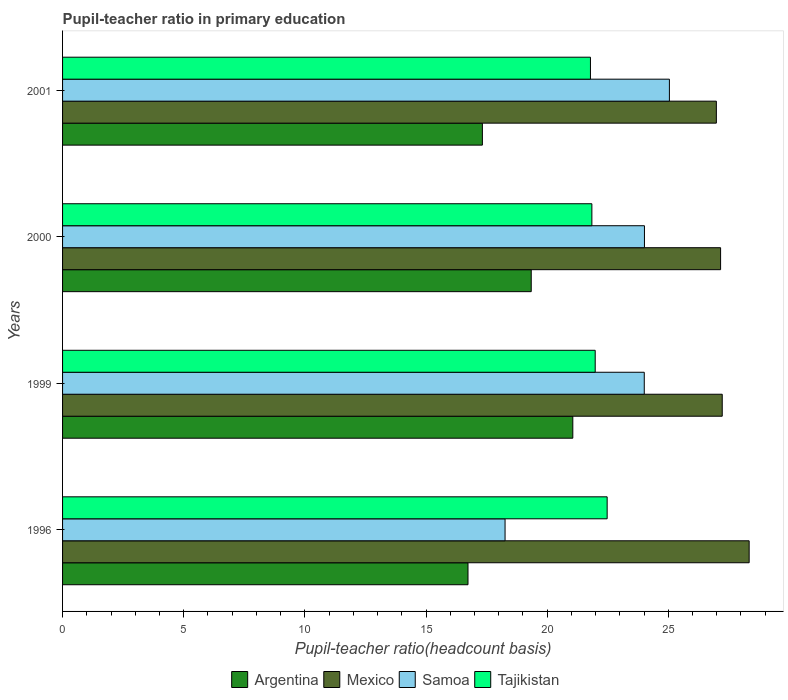Are the number of bars on each tick of the Y-axis equal?
Keep it short and to the point. Yes. What is the label of the 3rd group of bars from the top?
Your answer should be compact. 1999. What is the pupil-teacher ratio in primary education in Samoa in 1996?
Your answer should be very brief. 18.26. Across all years, what is the maximum pupil-teacher ratio in primary education in Mexico?
Ensure brevity in your answer.  28.34. Across all years, what is the minimum pupil-teacher ratio in primary education in Mexico?
Provide a succinct answer. 26.98. In which year was the pupil-teacher ratio in primary education in Mexico maximum?
Provide a short and direct response. 1996. What is the total pupil-teacher ratio in primary education in Mexico in the graph?
Ensure brevity in your answer.  109.7. What is the difference between the pupil-teacher ratio in primary education in Samoa in 1996 and that in 2001?
Provide a succinct answer. -6.78. What is the difference between the pupil-teacher ratio in primary education in Tajikistan in 1996 and the pupil-teacher ratio in primary education in Argentina in 2000?
Keep it short and to the point. 3.13. What is the average pupil-teacher ratio in primary education in Mexico per year?
Offer a very short reply. 27.43. In the year 2000, what is the difference between the pupil-teacher ratio in primary education in Samoa and pupil-teacher ratio in primary education in Argentina?
Offer a terse response. 4.67. What is the ratio of the pupil-teacher ratio in primary education in Argentina in 1999 to that in 2001?
Your answer should be very brief. 1.22. Is the pupil-teacher ratio in primary education in Tajikistan in 1999 less than that in 2000?
Make the answer very short. No. Is the difference between the pupil-teacher ratio in primary education in Samoa in 1999 and 2001 greater than the difference between the pupil-teacher ratio in primary education in Argentina in 1999 and 2001?
Keep it short and to the point. No. What is the difference between the highest and the second highest pupil-teacher ratio in primary education in Samoa?
Offer a terse response. 1.03. What is the difference between the highest and the lowest pupil-teacher ratio in primary education in Mexico?
Your answer should be compact. 1.35. In how many years, is the pupil-teacher ratio in primary education in Samoa greater than the average pupil-teacher ratio in primary education in Samoa taken over all years?
Provide a succinct answer. 3. Is it the case that in every year, the sum of the pupil-teacher ratio in primary education in Samoa and pupil-teacher ratio in primary education in Tajikistan is greater than the sum of pupil-teacher ratio in primary education in Argentina and pupil-teacher ratio in primary education in Mexico?
Provide a succinct answer. Yes. What does the 2nd bar from the top in 2001 represents?
Your answer should be compact. Samoa. What does the 2nd bar from the bottom in 1999 represents?
Your answer should be very brief. Mexico. Are all the bars in the graph horizontal?
Give a very brief answer. Yes. Are the values on the major ticks of X-axis written in scientific E-notation?
Offer a very short reply. No. Does the graph contain any zero values?
Your response must be concise. No. Where does the legend appear in the graph?
Your response must be concise. Bottom center. How many legend labels are there?
Offer a terse response. 4. How are the legend labels stacked?
Provide a short and direct response. Horizontal. What is the title of the graph?
Keep it short and to the point. Pupil-teacher ratio in primary education. What is the label or title of the X-axis?
Provide a succinct answer. Pupil-teacher ratio(headcount basis). What is the Pupil-teacher ratio(headcount basis) in Argentina in 1996?
Your answer should be very brief. 16.73. What is the Pupil-teacher ratio(headcount basis) in Mexico in 1996?
Your response must be concise. 28.34. What is the Pupil-teacher ratio(headcount basis) of Samoa in 1996?
Keep it short and to the point. 18.26. What is the Pupil-teacher ratio(headcount basis) of Tajikistan in 1996?
Your answer should be very brief. 22.48. What is the Pupil-teacher ratio(headcount basis) in Argentina in 1999?
Provide a succinct answer. 21.06. What is the Pupil-teacher ratio(headcount basis) in Mexico in 1999?
Provide a short and direct response. 27.23. What is the Pupil-teacher ratio(headcount basis) of Samoa in 1999?
Your answer should be very brief. 24.01. What is the Pupil-teacher ratio(headcount basis) in Tajikistan in 1999?
Provide a short and direct response. 21.98. What is the Pupil-teacher ratio(headcount basis) in Argentina in 2000?
Your answer should be compact. 19.34. What is the Pupil-teacher ratio(headcount basis) in Mexico in 2000?
Keep it short and to the point. 27.16. What is the Pupil-teacher ratio(headcount basis) of Samoa in 2000?
Your answer should be compact. 24.02. What is the Pupil-teacher ratio(headcount basis) in Tajikistan in 2000?
Provide a short and direct response. 21.85. What is the Pupil-teacher ratio(headcount basis) of Argentina in 2001?
Offer a very short reply. 17.33. What is the Pupil-teacher ratio(headcount basis) of Mexico in 2001?
Provide a succinct answer. 26.98. What is the Pupil-teacher ratio(headcount basis) of Samoa in 2001?
Ensure brevity in your answer.  25.05. What is the Pupil-teacher ratio(headcount basis) of Tajikistan in 2001?
Offer a very short reply. 21.79. Across all years, what is the maximum Pupil-teacher ratio(headcount basis) in Argentina?
Provide a succinct answer. 21.06. Across all years, what is the maximum Pupil-teacher ratio(headcount basis) in Mexico?
Offer a very short reply. 28.34. Across all years, what is the maximum Pupil-teacher ratio(headcount basis) of Samoa?
Give a very brief answer. 25.05. Across all years, what is the maximum Pupil-teacher ratio(headcount basis) of Tajikistan?
Provide a short and direct response. 22.48. Across all years, what is the minimum Pupil-teacher ratio(headcount basis) of Argentina?
Provide a succinct answer. 16.73. Across all years, what is the minimum Pupil-teacher ratio(headcount basis) of Mexico?
Ensure brevity in your answer.  26.98. Across all years, what is the minimum Pupil-teacher ratio(headcount basis) of Samoa?
Offer a terse response. 18.26. Across all years, what is the minimum Pupil-teacher ratio(headcount basis) in Tajikistan?
Your answer should be compact. 21.79. What is the total Pupil-teacher ratio(headcount basis) in Argentina in the graph?
Provide a succinct answer. 74.46. What is the total Pupil-teacher ratio(headcount basis) in Mexico in the graph?
Keep it short and to the point. 109.7. What is the total Pupil-teacher ratio(headcount basis) in Samoa in the graph?
Make the answer very short. 91.33. What is the total Pupil-teacher ratio(headcount basis) of Tajikistan in the graph?
Your response must be concise. 88.09. What is the difference between the Pupil-teacher ratio(headcount basis) in Argentina in 1996 and that in 1999?
Your answer should be compact. -4.33. What is the difference between the Pupil-teacher ratio(headcount basis) of Mexico in 1996 and that in 1999?
Provide a short and direct response. 1.11. What is the difference between the Pupil-teacher ratio(headcount basis) of Samoa in 1996 and that in 1999?
Make the answer very short. -5.74. What is the difference between the Pupil-teacher ratio(headcount basis) of Tajikistan in 1996 and that in 1999?
Your answer should be very brief. 0.49. What is the difference between the Pupil-teacher ratio(headcount basis) of Argentina in 1996 and that in 2000?
Offer a terse response. -2.61. What is the difference between the Pupil-teacher ratio(headcount basis) in Mexico in 1996 and that in 2000?
Keep it short and to the point. 1.18. What is the difference between the Pupil-teacher ratio(headcount basis) in Samoa in 1996 and that in 2000?
Give a very brief answer. -5.75. What is the difference between the Pupil-teacher ratio(headcount basis) of Tajikistan in 1996 and that in 2000?
Offer a very short reply. 0.63. What is the difference between the Pupil-teacher ratio(headcount basis) in Argentina in 1996 and that in 2001?
Offer a very short reply. -0.59. What is the difference between the Pupil-teacher ratio(headcount basis) in Mexico in 1996 and that in 2001?
Give a very brief answer. 1.35. What is the difference between the Pupil-teacher ratio(headcount basis) of Samoa in 1996 and that in 2001?
Give a very brief answer. -6.78. What is the difference between the Pupil-teacher ratio(headcount basis) in Tajikistan in 1996 and that in 2001?
Keep it short and to the point. 0.69. What is the difference between the Pupil-teacher ratio(headcount basis) in Argentina in 1999 and that in 2000?
Your response must be concise. 1.72. What is the difference between the Pupil-teacher ratio(headcount basis) of Mexico in 1999 and that in 2000?
Offer a terse response. 0.07. What is the difference between the Pupil-teacher ratio(headcount basis) in Samoa in 1999 and that in 2000?
Make the answer very short. -0.01. What is the difference between the Pupil-teacher ratio(headcount basis) in Tajikistan in 1999 and that in 2000?
Offer a terse response. 0.14. What is the difference between the Pupil-teacher ratio(headcount basis) in Argentina in 1999 and that in 2001?
Make the answer very short. 3.73. What is the difference between the Pupil-teacher ratio(headcount basis) of Mexico in 1999 and that in 2001?
Offer a very short reply. 0.24. What is the difference between the Pupil-teacher ratio(headcount basis) of Samoa in 1999 and that in 2001?
Provide a succinct answer. -1.04. What is the difference between the Pupil-teacher ratio(headcount basis) of Tajikistan in 1999 and that in 2001?
Provide a succinct answer. 0.2. What is the difference between the Pupil-teacher ratio(headcount basis) in Argentina in 2000 and that in 2001?
Ensure brevity in your answer.  2.02. What is the difference between the Pupil-teacher ratio(headcount basis) in Mexico in 2000 and that in 2001?
Your answer should be very brief. 0.17. What is the difference between the Pupil-teacher ratio(headcount basis) in Samoa in 2000 and that in 2001?
Give a very brief answer. -1.03. What is the difference between the Pupil-teacher ratio(headcount basis) in Tajikistan in 2000 and that in 2001?
Your answer should be compact. 0.06. What is the difference between the Pupil-teacher ratio(headcount basis) in Argentina in 1996 and the Pupil-teacher ratio(headcount basis) in Mexico in 1999?
Make the answer very short. -10.49. What is the difference between the Pupil-teacher ratio(headcount basis) in Argentina in 1996 and the Pupil-teacher ratio(headcount basis) in Samoa in 1999?
Provide a short and direct response. -7.27. What is the difference between the Pupil-teacher ratio(headcount basis) of Argentina in 1996 and the Pupil-teacher ratio(headcount basis) of Tajikistan in 1999?
Your response must be concise. -5.25. What is the difference between the Pupil-teacher ratio(headcount basis) of Mexico in 1996 and the Pupil-teacher ratio(headcount basis) of Samoa in 1999?
Make the answer very short. 4.33. What is the difference between the Pupil-teacher ratio(headcount basis) in Mexico in 1996 and the Pupil-teacher ratio(headcount basis) in Tajikistan in 1999?
Your answer should be very brief. 6.35. What is the difference between the Pupil-teacher ratio(headcount basis) in Samoa in 1996 and the Pupil-teacher ratio(headcount basis) in Tajikistan in 1999?
Your response must be concise. -3.72. What is the difference between the Pupil-teacher ratio(headcount basis) in Argentina in 1996 and the Pupil-teacher ratio(headcount basis) in Mexico in 2000?
Offer a very short reply. -10.42. What is the difference between the Pupil-teacher ratio(headcount basis) of Argentina in 1996 and the Pupil-teacher ratio(headcount basis) of Samoa in 2000?
Provide a succinct answer. -7.28. What is the difference between the Pupil-teacher ratio(headcount basis) in Argentina in 1996 and the Pupil-teacher ratio(headcount basis) in Tajikistan in 2000?
Give a very brief answer. -5.11. What is the difference between the Pupil-teacher ratio(headcount basis) in Mexico in 1996 and the Pupil-teacher ratio(headcount basis) in Samoa in 2000?
Your response must be concise. 4.32. What is the difference between the Pupil-teacher ratio(headcount basis) of Mexico in 1996 and the Pupil-teacher ratio(headcount basis) of Tajikistan in 2000?
Offer a very short reply. 6.49. What is the difference between the Pupil-teacher ratio(headcount basis) of Samoa in 1996 and the Pupil-teacher ratio(headcount basis) of Tajikistan in 2000?
Ensure brevity in your answer.  -3.58. What is the difference between the Pupil-teacher ratio(headcount basis) of Argentina in 1996 and the Pupil-teacher ratio(headcount basis) of Mexico in 2001?
Give a very brief answer. -10.25. What is the difference between the Pupil-teacher ratio(headcount basis) in Argentina in 1996 and the Pupil-teacher ratio(headcount basis) in Samoa in 2001?
Offer a very short reply. -8.31. What is the difference between the Pupil-teacher ratio(headcount basis) in Argentina in 1996 and the Pupil-teacher ratio(headcount basis) in Tajikistan in 2001?
Provide a succinct answer. -5.05. What is the difference between the Pupil-teacher ratio(headcount basis) of Mexico in 1996 and the Pupil-teacher ratio(headcount basis) of Samoa in 2001?
Provide a short and direct response. 3.29. What is the difference between the Pupil-teacher ratio(headcount basis) in Mexico in 1996 and the Pupil-teacher ratio(headcount basis) in Tajikistan in 2001?
Your response must be concise. 6.55. What is the difference between the Pupil-teacher ratio(headcount basis) in Samoa in 1996 and the Pupil-teacher ratio(headcount basis) in Tajikistan in 2001?
Your answer should be very brief. -3.52. What is the difference between the Pupil-teacher ratio(headcount basis) of Argentina in 1999 and the Pupil-teacher ratio(headcount basis) of Mexico in 2000?
Provide a succinct answer. -6.1. What is the difference between the Pupil-teacher ratio(headcount basis) in Argentina in 1999 and the Pupil-teacher ratio(headcount basis) in Samoa in 2000?
Provide a succinct answer. -2.96. What is the difference between the Pupil-teacher ratio(headcount basis) in Argentina in 1999 and the Pupil-teacher ratio(headcount basis) in Tajikistan in 2000?
Offer a terse response. -0.79. What is the difference between the Pupil-teacher ratio(headcount basis) in Mexico in 1999 and the Pupil-teacher ratio(headcount basis) in Samoa in 2000?
Give a very brief answer. 3.21. What is the difference between the Pupil-teacher ratio(headcount basis) in Mexico in 1999 and the Pupil-teacher ratio(headcount basis) in Tajikistan in 2000?
Offer a terse response. 5.38. What is the difference between the Pupil-teacher ratio(headcount basis) in Samoa in 1999 and the Pupil-teacher ratio(headcount basis) in Tajikistan in 2000?
Make the answer very short. 2.16. What is the difference between the Pupil-teacher ratio(headcount basis) of Argentina in 1999 and the Pupil-teacher ratio(headcount basis) of Mexico in 2001?
Keep it short and to the point. -5.92. What is the difference between the Pupil-teacher ratio(headcount basis) in Argentina in 1999 and the Pupil-teacher ratio(headcount basis) in Samoa in 2001?
Keep it short and to the point. -3.99. What is the difference between the Pupil-teacher ratio(headcount basis) of Argentina in 1999 and the Pupil-teacher ratio(headcount basis) of Tajikistan in 2001?
Offer a terse response. -0.73. What is the difference between the Pupil-teacher ratio(headcount basis) in Mexico in 1999 and the Pupil-teacher ratio(headcount basis) in Samoa in 2001?
Offer a terse response. 2.18. What is the difference between the Pupil-teacher ratio(headcount basis) in Mexico in 1999 and the Pupil-teacher ratio(headcount basis) in Tajikistan in 2001?
Your answer should be compact. 5.44. What is the difference between the Pupil-teacher ratio(headcount basis) in Samoa in 1999 and the Pupil-teacher ratio(headcount basis) in Tajikistan in 2001?
Provide a short and direct response. 2.22. What is the difference between the Pupil-teacher ratio(headcount basis) in Argentina in 2000 and the Pupil-teacher ratio(headcount basis) in Mexico in 2001?
Your answer should be very brief. -7.64. What is the difference between the Pupil-teacher ratio(headcount basis) in Argentina in 2000 and the Pupil-teacher ratio(headcount basis) in Samoa in 2001?
Offer a very short reply. -5.7. What is the difference between the Pupil-teacher ratio(headcount basis) in Argentina in 2000 and the Pupil-teacher ratio(headcount basis) in Tajikistan in 2001?
Give a very brief answer. -2.44. What is the difference between the Pupil-teacher ratio(headcount basis) of Mexico in 2000 and the Pupil-teacher ratio(headcount basis) of Samoa in 2001?
Ensure brevity in your answer.  2.11. What is the difference between the Pupil-teacher ratio(headcount basis) in Mexico in 2000 and the Pupil-teacher ratio(headcount basis) in Tajikistan in 2001?
Provide a succinct answer. 5.37. What is the difference between the Pupil-teacher ratio(headcount basis) in Samoa in 2000 and the Pupil-teacher ratio(headcount basis) in Tajikistan in 2001?
Give a very brief answer. 2.23. What is the average Pupil-teacher ratio(headcount basis) in Argentina per year?
Your answer should be very brief. 18.62. What is the average Pupil-teacher ratio(headcount basis) in Mexico per year?
Offer a very short reply. 27.43. What is the average Pupil-teacher ratio(headcount basis) of Samoa per year?
Your answer should be compact. 22.83. What is the average Pupil-teacher ratio(headcount basis) of Tajikistan per year?
Offer a terse response. 22.02. In the year 1996, what is the difference between the Pupil-teacher ratio(headcount basis) in Argentina and Pupil-teacher ratio(headcount basis) in Mexico?
Give a very brief answer. -11.6. In the year 1996, what is the difference between the Pupil-teacher ratio(headcount basis) of Argentina and Pupil-teacher ratio(headcount basis) of Samoa?
Your response must be concise. -1.53. In the year 1996, what is the difference between the Pupil-teacher ratio(headcount basis) of Argentina and Pupil-teacher ratio(headcount basis) of Tajikistan?
Your response must be concise. -5.74. In the year 1996, what is the difference between the Pupil-teacher ratio(headcount basis) of Mexico and Pupil-teacher ratio(headcount basis) of Samoa?
Provide a succinct answer. 10.07. In the year 1996, what is the difference between the Pupil-teacher ratio(headcount basis) of Mexico and Pupil-teacher ratio(headcount basis) of Tajikistan?
Offer a terse response. 5.86. In the year 1996, what is the difference between the Pupil-teacher ratio(headcount basis) of Samoa and Pupil-teacher ratio(headcount basis) of Tajikistan?
Your response must be concise. -4.21. In the year 1999, what is the difference between the Pupil-teacher ratio(headcount basis) in Argentina and Pupil-teacher ratio(headcount basis) in Mexico?
Offer a very short reply. -6.17. In the year 1999, what is the difference between the Pupil-teacher ratio(headcount basis) in Argentina and Pupil-teacher ratio(headcount basis) in Samoa?
Your answer should be compact. -2.95. In the year 1999, what is the difference between the Pupil-teacher ratio(headcount basis) of Argentina and Pupil-teacher ratio(headcount basis) of Tajikistan?
Provide a succinct answer. -0.92. In the year 1999, what is the difference between the Pupil-teacher ratio(headcount basis) of Mexico and Pupil-teacher ratio(headcount basis) of Samoa?
Offer a very short reply. 3.22. In the year 1999, what is the difference between the Pupil-teacher ratio(headcount basis) in Mexico and Pupil-teacher ratio(headcount basis) in Tajikistan?
Provide a succinct answer. 5.24. In the year 1999, what is the difference between the Pupil-teacher ratio(headcount basis) in Samoa and Pupil-teacher ratio(headcount basis) in Tajikistan?
Your response must be concise. 2.02. In the year 2000, what is the difference between the Pupil-teacher ratio(headcount basis) in Argentina and Pupil-teacher ratio(headcount basis) in Mexico?
Keep it short and to the point. -7.82. In the year 2000, what is the difference between the Pupil-teacher ratio(headcount basis) of Argentina and Pupil-teacher ratio(headcount basis) of Samoa?
Provide a short and direct response. -4.67. In the year 2000, what is the difference between the Pupil-teacher ratio(headcount basis) of Argentina and Pupil-teacher ratio(headcount basis) of Tajikistan?
Your answer should be compact. -2.5. In the year 2000, what is the difference between the Pupil-teacher ratio(headcount basis) of Mexico and Pupil-teacher ratio(headcount basis) of Samoa?
Keep it short and to the point. 3.14. In the year 2000, what is the difference between the Pupil-teacher ratio(headcount basis) of Mexico and Pupil-teacher ratio(headcount basis) of Tajikistan?
Ensure brevity in your answer.  5.31. In the year 2000, what is the difference between the Pupil-teacher ratio(headcount basis) in Samoa and Pupil-teacher ratio(headcount basis) in Tajikistan?
Offer a very short reply. 2.17. In the year 2001, what is the difference between the Pupil-teacher ratio(headcount basis) of Argentina and Pupil-teacher ratio(headcount basis) of Mexico?
Make the answer very short. -9.66. In the year 2001, what is the difference between the Pupil-teacher ratio(headcount basis) in Argentina and Pupil-teacher ratio(headcount basis) in Samoa?
Provide a short and direct response. -7.72. In the year 2001, what is the difference between the Pupil-teacher ratio(headcount basis) of Argentina and Pupil-teacher ratio(headcount basis) of Tajikistan?
Keep it short and to the point. -4.46. In the year 2001, what is the difference between the Pupil-teacher ratio(headcount basis) in Mexico and Pupil-teacher ratio(headcount basis) in Samoa?
Make the answer very short. 1.94. In the year 2001, what is the difference between the Pupil-teacher ratio(headcount basis) in Mexico and Pupil-teacher ratio(headcount basis) in Tajikistan?
Your answer should be compact. 5.2. In the year 2001, what is the difference between the Pupil-teacher ratio(headcount basis) of Samoa and Pupil-teacher ratio(headcount basis) of Tajikistan?
Give a very brief answer. 3.26. What is the ratio of the Pupil-teacher ratio(headcount basis) in Argentina in 1996 to that in 1999?
Offer a very short reply. 0.79. What is the ratio of the Pupil-teacher ratio(headcount basis) of Mexico in 1996 to that in 1999?
Provide a succinct answer. 1.04. What is the ratio of the Pupil-teacher ratio(headcount basis) of Samoa in 1996 to that in 1999?
Ensure brevity in your answer.  0.76. What is the ratio of the Pupil-teacher ratio(headcount basis) of Tajikistan in 1996 to that in 1999?
Give a very brief answer. 1.02. What is the ratio of the Pupil-teacher ratio(headcount basis) in Argentina in 1996 to that in 2000?
Your response must be concise. 0.87. What is the ratio of the Pupil-teacher ratio(headcount basis) of Mexico in 1996 to that in 2000?
Your response must be concise. 1.04. What is the ratio of the Pupil-teacher ratio(headcount basis) of Samoa in 1996 to that in 2000?
Provide a succinct answer. 0.76. What is the ratio of the Pupil-teacher ratio(headcount basis) of Tajikistan in 1996 to that in 2000?
Your answer should be compact. 1.03. What is the ratio of the Pupil-teacher ratio(headcount basis) of Argentina in 1996 to that in 2001?
Make the answer very short. 0.97. What is the ratio of the Pupil-teacher ratio(headcount basis) of Mexico in 1996 to that in 2001?
Your response must be concise. 1.05. What is the ratio of the Pupil-teacher ratio(headcount basis) in Samoa in 1996 to that in 2001?
Offer a very short reply. 0.73. What is the ratio of the Pupil-teacher ratio(headcount basis) of Tajikistan in 1996 to that in 2001?
Ensure brevity in your answer.  1.03. What is the ratio of the Pupil-teacher ratio(headcount basis) in Argentina in 1999 to that in 2000?
Your response must be concise. 1.09. What is the ratio of the Pupil-teacher ratio(headcount basis) in Mexico in 1999 to that in 2000?
Ensure brevity in your answer.  1. What is the ratio of the Pupil-teacher ratio(headcount basis) of Argentina in 1999 to that in 2001?
Make the answer very short. 1.22. What is the ratio of the Pupil-teacher ratio(headcount basis) of Mexico in 1999 to that in 2001?
Offer a very short reply. 1.01. What is the ratio of the Pupil-teacher ratio(headcount basis) of Samoa in 1999 to that in 2001?
Provide a short and direct response. 0.96. What is the ratio of the Pupil-teacher ratio(headcount basis) in Argentina in 2000 to that in 2001?
Provide a short and direct response. 1.12. What is the ratio of the Pupil-teacher ratio(headcount basis) of Mexico in 2000 to that in 2001?
Offer a terse response. 1.01. What is the ratio of the Pupil-teacher ratio(headcount basis) in Samoa in 2000 to that in 2001?
Ensure brevity in your answer.  0.96. What is the ratio of the Pupil-teacher ratio(headcount basis) in Tajikistan in 2000 to that in 2001?
Ensure brevity in your answer.  1. What is the difference between the highest and the second highest Pupil-teacher ratio(headcount basis) of Argentina?
Your answer should be very brief. 1.72. What is the difference between the highest and the second highest Pupil-teacher ratio(headcount basis) in Mexico?
Your response must be concise. 1.11. What is the difference between the highest and the second highest Pupil-teacher ratio(headcount basis) of Tajikistan?
Your answer should be very brief. 0.49. What is the difference between the highest and the lowest Pupil-teacher ratio(headcount basis) of Argentina?
Keep it short and to the point. 4.33. What is the difference between the highest and the lowest Pupil-teacher ratio(headcount basis) in Mexico?
Make the answer very short. 1.35. What is the difference between the highest and the lowest Pupil-teacher ratio(headcount basis) in Samoa?
Keep it short and to the point. 6.78. What is the difference between the highest and the lowest Pupil-teacher ratio(headcount basis) in Tajikistan?
Your answer should be compact. 0.69. 